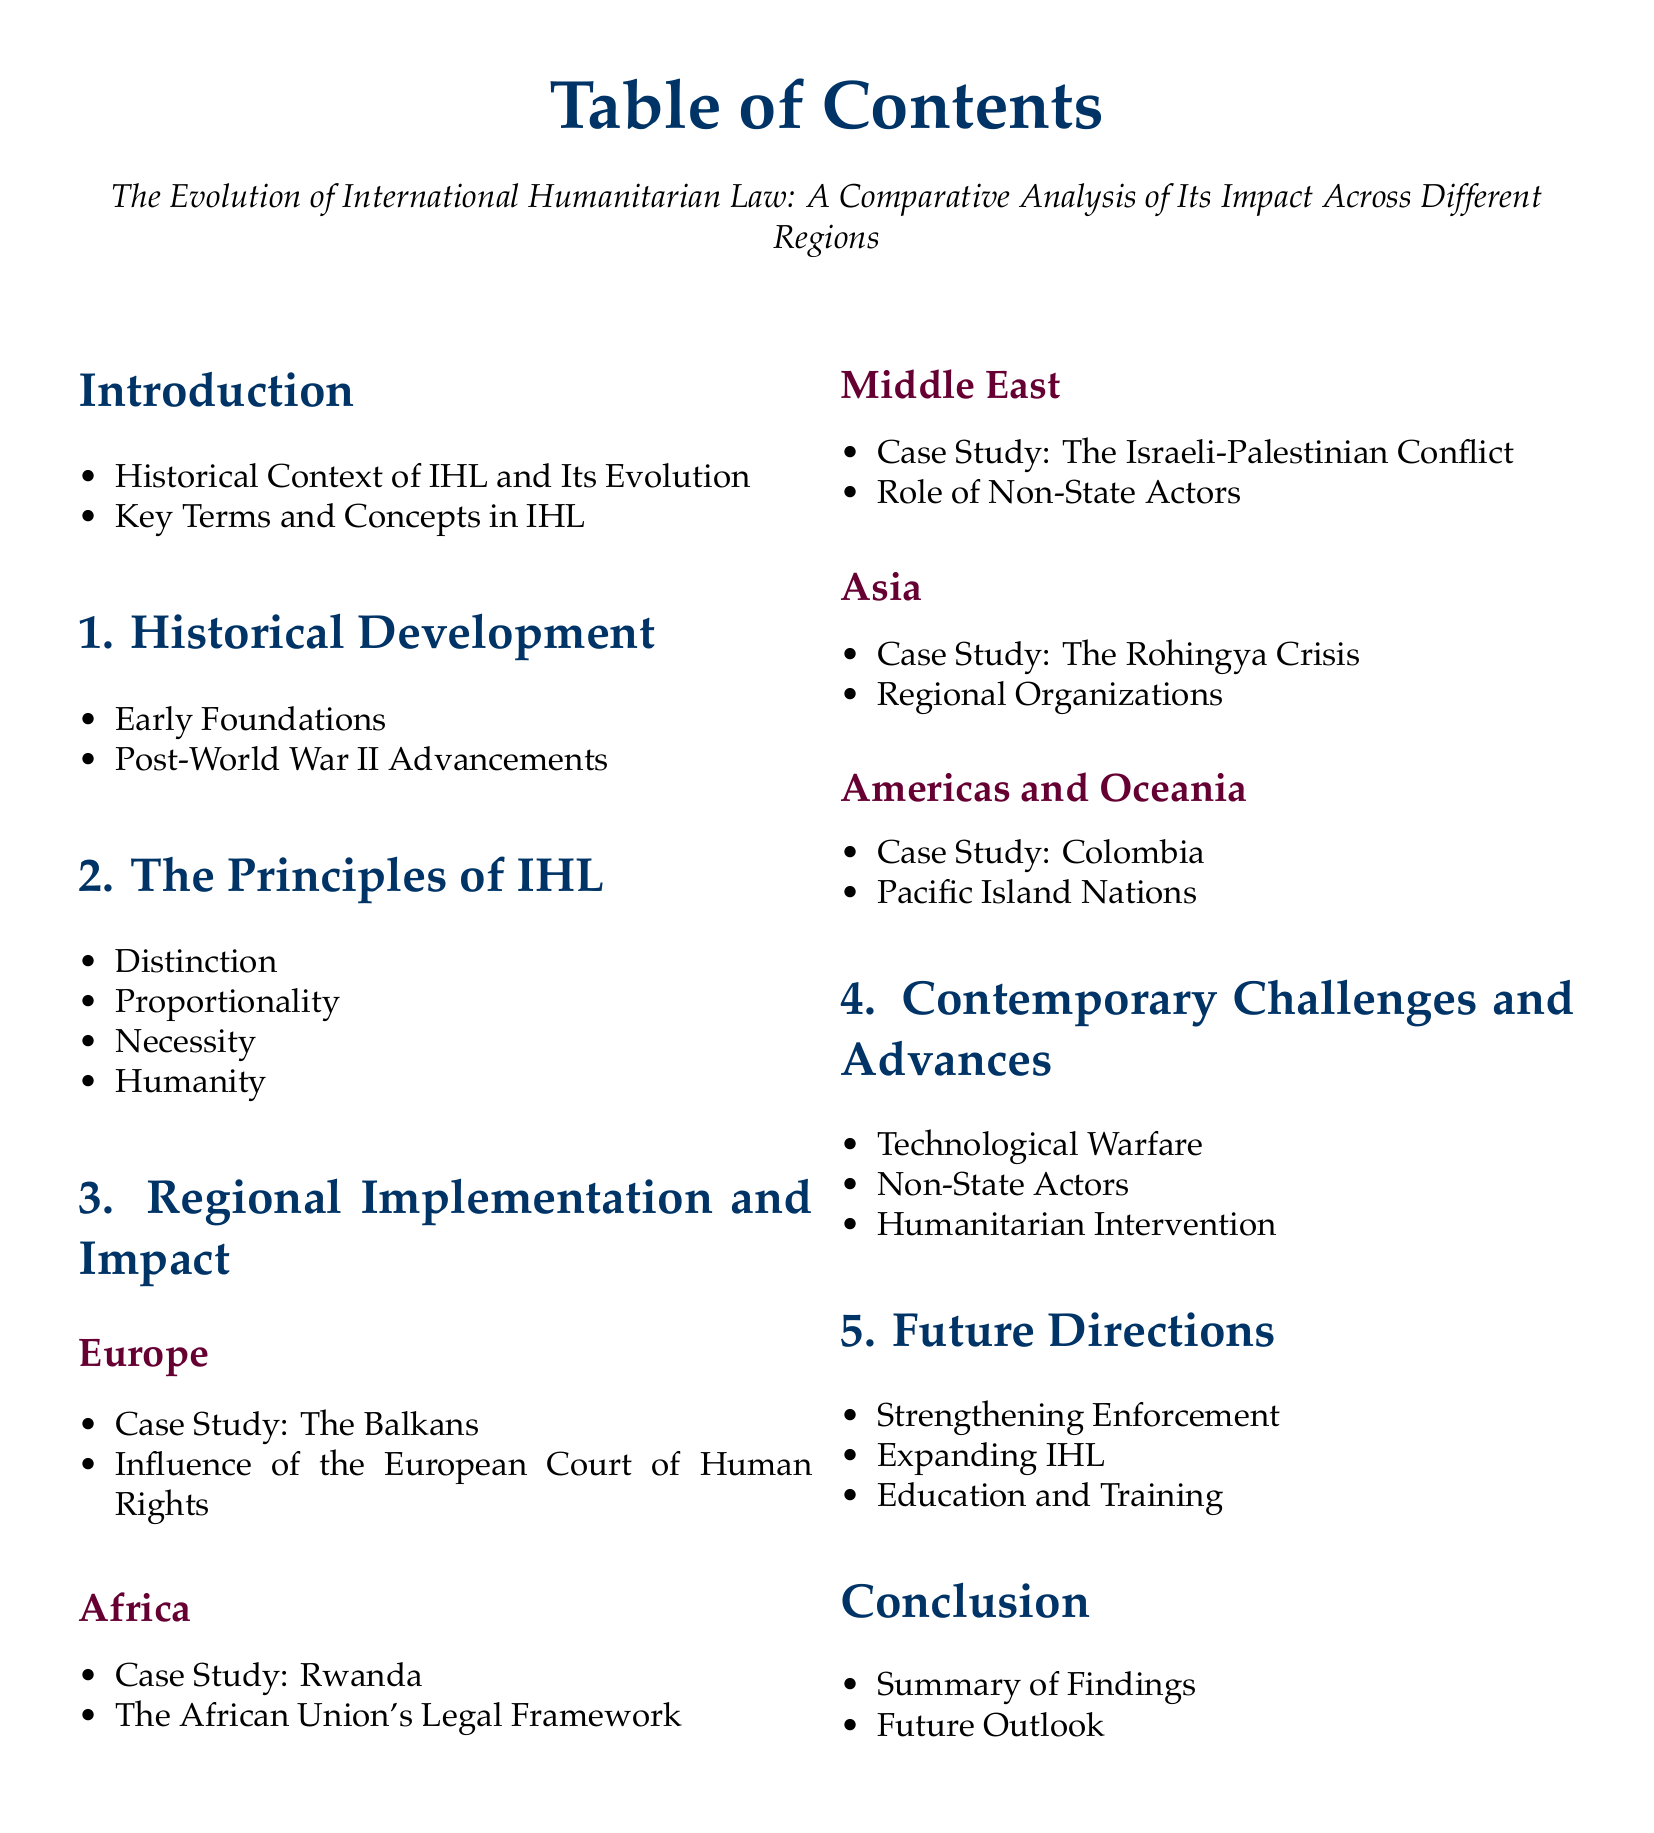What is the title of the document? The title is stated in the center of the document, which is "The Evolution of International Humanitarian Law: A Comparative Analysis of Its Impact Across Different Regions."
Answer: The Evolution of International Humanitarian Law: A Comparative Analysis of Its Impact Across Different Regions How many sections are there in the document? The document lists a total of six main sections after the introduction.
Answer: six Which region has a case study on the Rohingya Crisis? The document includes a specific case study under the Asia subsection regarding the Rohingya Crisis.
Answer: Asia What is the principle of IHL listed after proportionality? The document presents the principles of IHL in a specific order, placing "Necessity" after "Proportionality."
Answer: Necessity What does the section titled "Future Directions" include? The section outlines three main points regarding future directions, one of which is "Strengthening Enforcement."
Answer: Strengthening Enforcement Which case study is mentioned under the Africa subsection? The document specifies "Rwanda" as a case study in the Africa regional subsection.
Answer: Rwanda What technology-related challenge is mentioned in the contemporary challenges section? One of the challenges listed in this section is "Technological Warfare."
Answer: Technological Warfare What type of organizations are mentioned under the Asia section? The Asia subsection mentions the involvement of "Regional Organizations."
Answer: Regional Organizations What is the last item listed in the conclusion section? The conclusion section wraps up with a final point about a "Future Outlook."
Answer: Future Outlook 